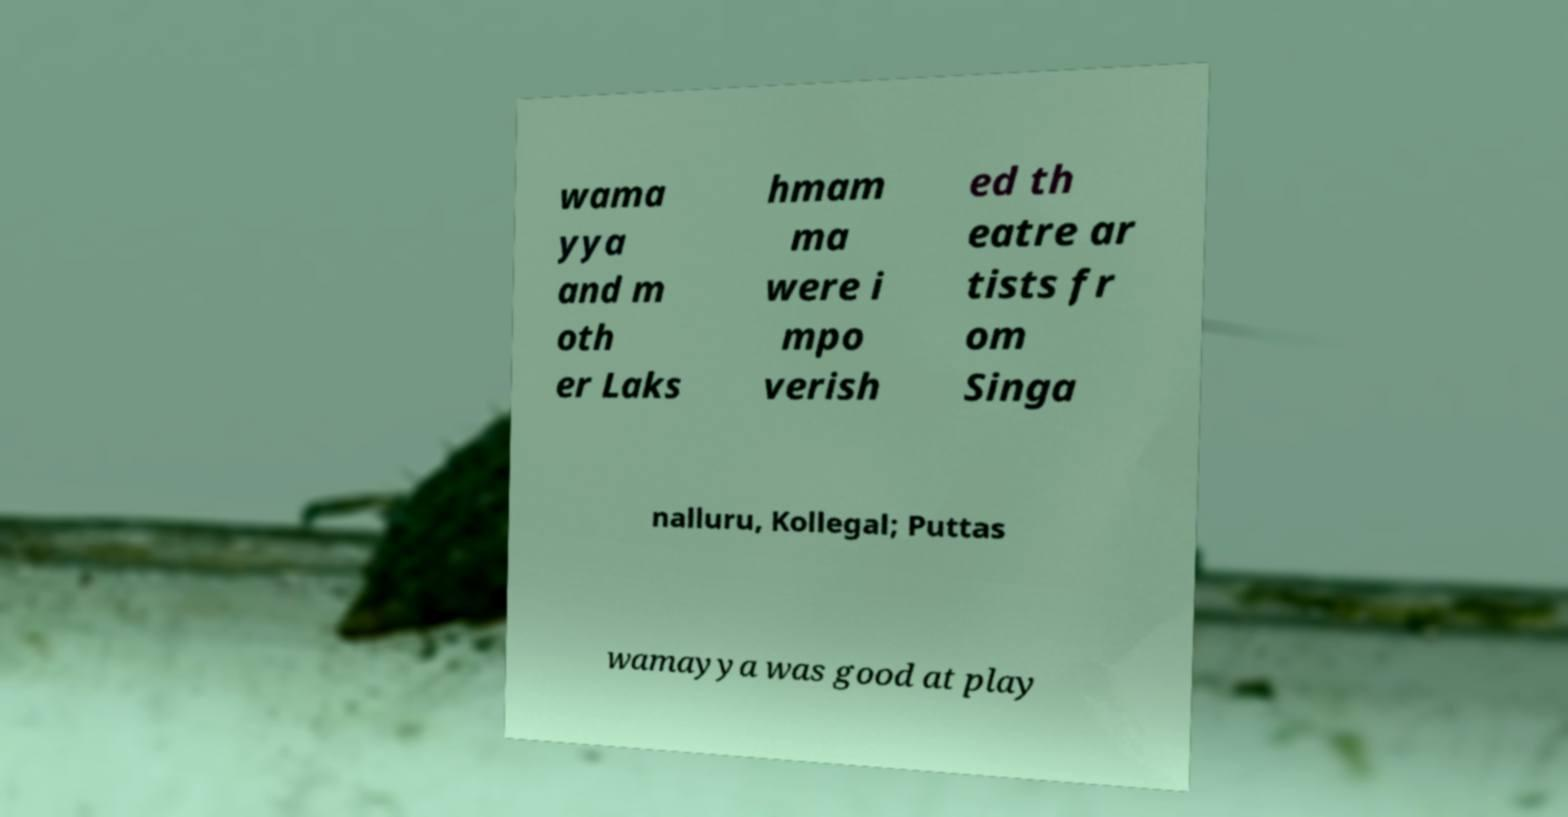Please read and relay the text visible in this image. What does it say? wama yya and m oth er Laks hmam ma were i mpo verish ed th eatre ar tists fr om Singa nalluru, Kollegal; Puttas wamayya was good at play 